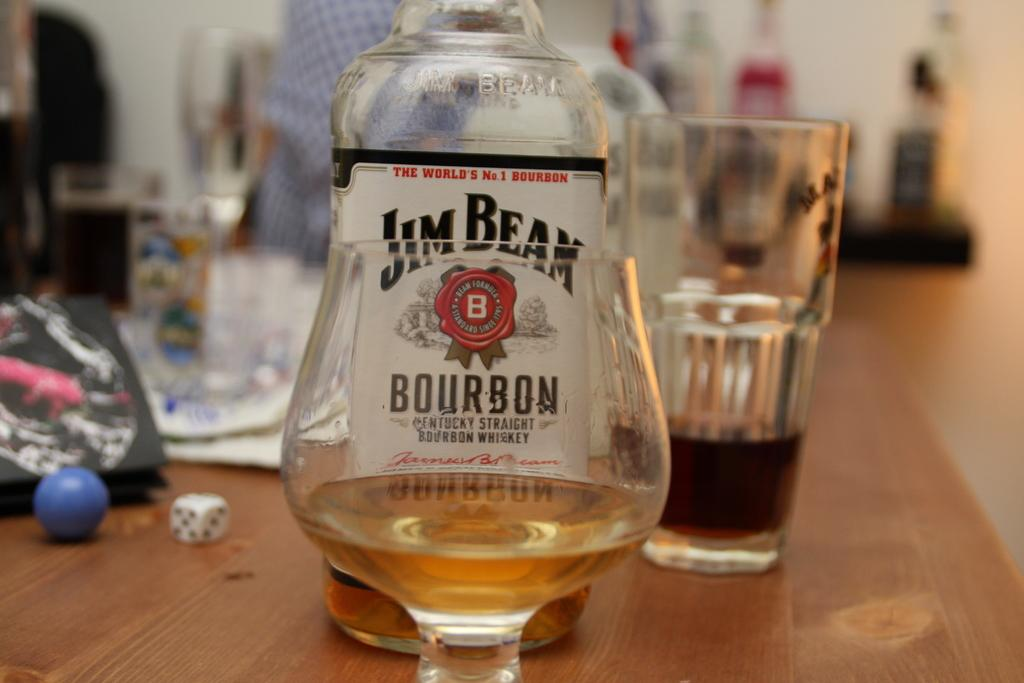<image>
Relay a brief, clear account of the picture shown. A glass that is placed next to a bottle of Jim Beam. 